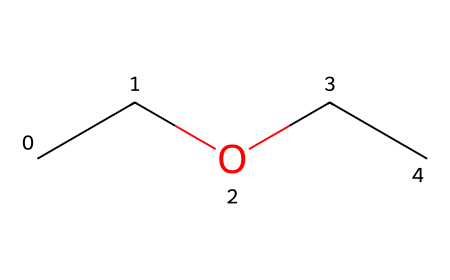What is the chemical name of this compound? The SMILES representation, "CCOCC", corresponds to diethyl ether, which is a common name for the compound. The structure contains two ethyl groups (represented by "CC"), connected by an oxygen atom (represented by "O").
Answer: diethyl ether How many carbon atoms are present in the structure? By examining the SMILES representation "CCOCC", we can count the carbon atoms: there are two "CC" segments which each represent two carbon atoms, resulting in a total of four carbon atoms.
Answer: 4 What type of bond connects the carbon atoms to the oxygen atom? In the structure "CCOCC", the carbon atoms are connected to the oxygen atom through single covalent bonds, which is indicated by their linear arrangement around the oxygen without any double or triple bonds.
Answer: single bond How many hydrogen atoms are associated with this molecule? To determine the number of hydrogen atoms, we analyze the carbon atoms first. Each carbon in an ether typically forms four bonds: with the oxygen and three hydrogens if it’s in a terminal position. For the two ethyl groups, we add two carbons with 5 hydrogens each, plus 1 from the intermediate carbon connecting to oxygen, yielding a total of 10 hydrogen atoms.
Answer: 10 What type of chemical is diethyl ether classified as? Diethyl ether, represented by the SMILES "CCOCC," is classified as an ether due to the presence of an oxygen atom that connects two alkyl or aryl groups—in this case, the ethyl groups. This classification is typical for compounds where an oxygen atom is bonded to two carbon-containing groups.
Answer: ether What functional group is present in diethyl ether? The presence of the oxygen atom connecting the two ethyl groups indicates that the functional group is an ether functional group, characterized by the R-O-R' structure (where R and R' are alkyl groups). This specific arrangement defines ethers.
Answer: ether group 